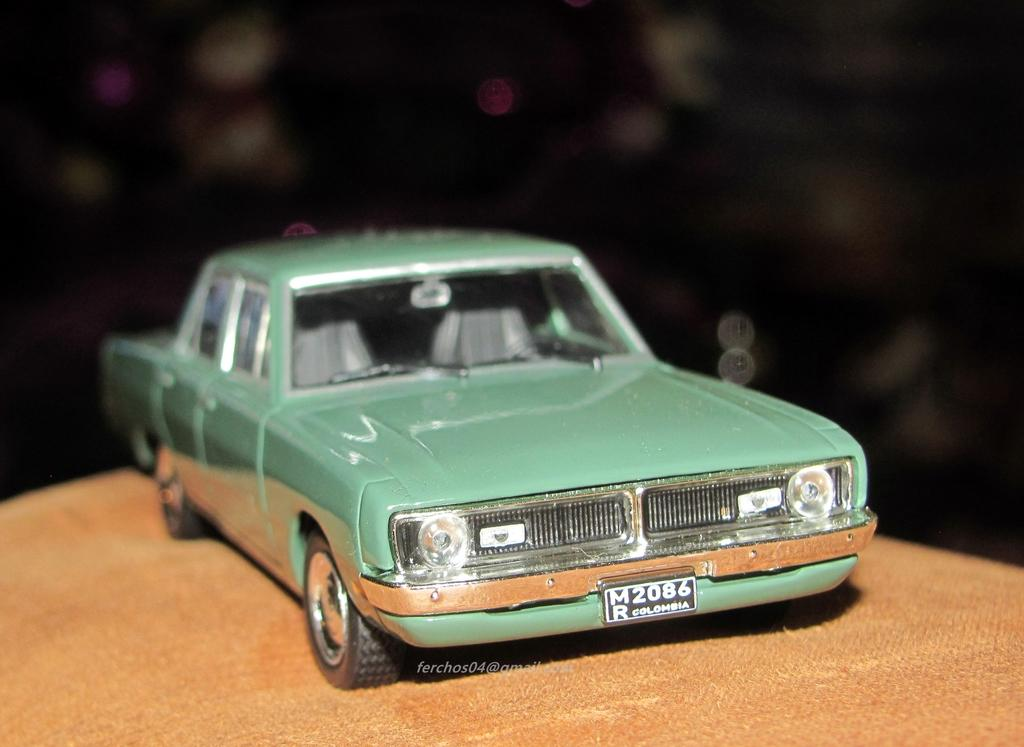What is the main object in the image? There is a car toy in the image. What is the car toy placed on? The car toy is placed on a cloth. How many babies are playing with the kettle in the image? There are no babies or kettle present in the image; it only features a car toy placed on a cloth. 